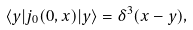Convert formula to latex. <formula><loc_0><loc_0><loc_500><loc_500>\langle y | j _ { 0 } ( 0 , x ) | y \rangle = \delta ^ { 3 } ( x - y ) ,</formula> 